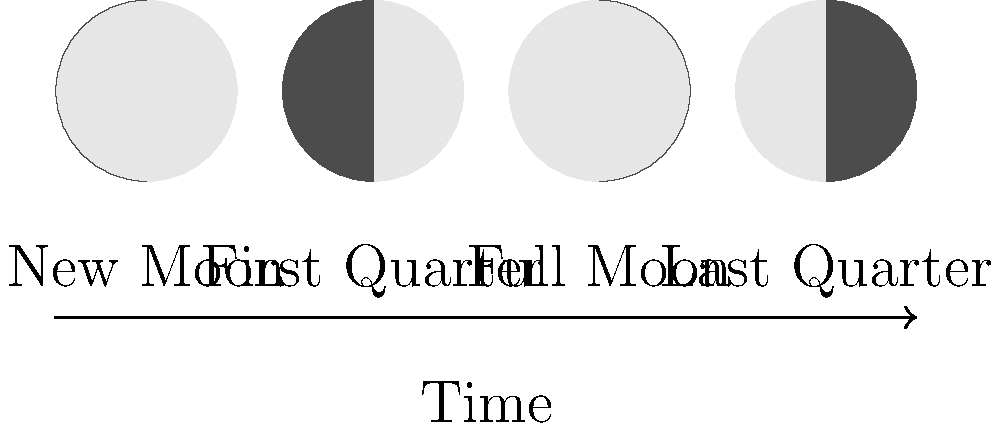How might the activity patterns of nocturnal animals, such as owls or bats, be affected by the lunar phases shown in the diagram, and what implications could this have for your virtual reality mapping of their habitats? 1. Lunar phases and illumination:
   - New Moon: Minimal moonlight, darkest nights
   - First Quarter: Moderate illumination, moon sets around midnight
   - Full Moon: Maximum illumination throughout the night
   - Last Quarter: Moderate illumination, moon rises around midnight

2. Effect on nocturnal animal behavior:
   a) Prey species (e.g., small mammals):
      - Tend to reduce activity during brighter nights (Full Moon)
      - Increase activity during darker nights (New Moon)
   b) Predators (e.g., owls, bats):
      - May have increased hunting success during Full Moon due to better visibility
      - Might adjust hunting strategies during New Moon to compensate for reduced visibility

3. Implications for virtual reality mapping:
   a) Temporal variations:
      - Need to incorporate time-based data to reflect changing animal behaviors across lunar phases
   b) Spatial variations:
      - Map different habitat use patterns based on moonlight intensity
      - Highlight areas of increased or decreased activity during specific lunar phases

4. Considerations for mapping:
   a) Layer lunar phase information onto habitat maps
   b) Include moonlight intensity as a variable in animal movement models
   c) Create separate maps for each lunar phase to show behavioral changes

5. Research applications:
   a) Study predator-prey interactions across lunar cycles
   b) Analyze habitat use efficiency in relation to moonlight
   c) Investigate potential impacts of artificial light pollution on natural lunar-driven behaviors

6. Conservation implications:
   - Use findings to inform wildlife management practices
   - Develop strategies to mitigate human activities that may disrupt lunar-influenced behaviors
Answer: Nocturnal animal activity varies with lunar phases, affecting habitat use patterns; VR maps should incorporate lunar cycle data to accurately represent temporal and spatial variations in animal behavior. 